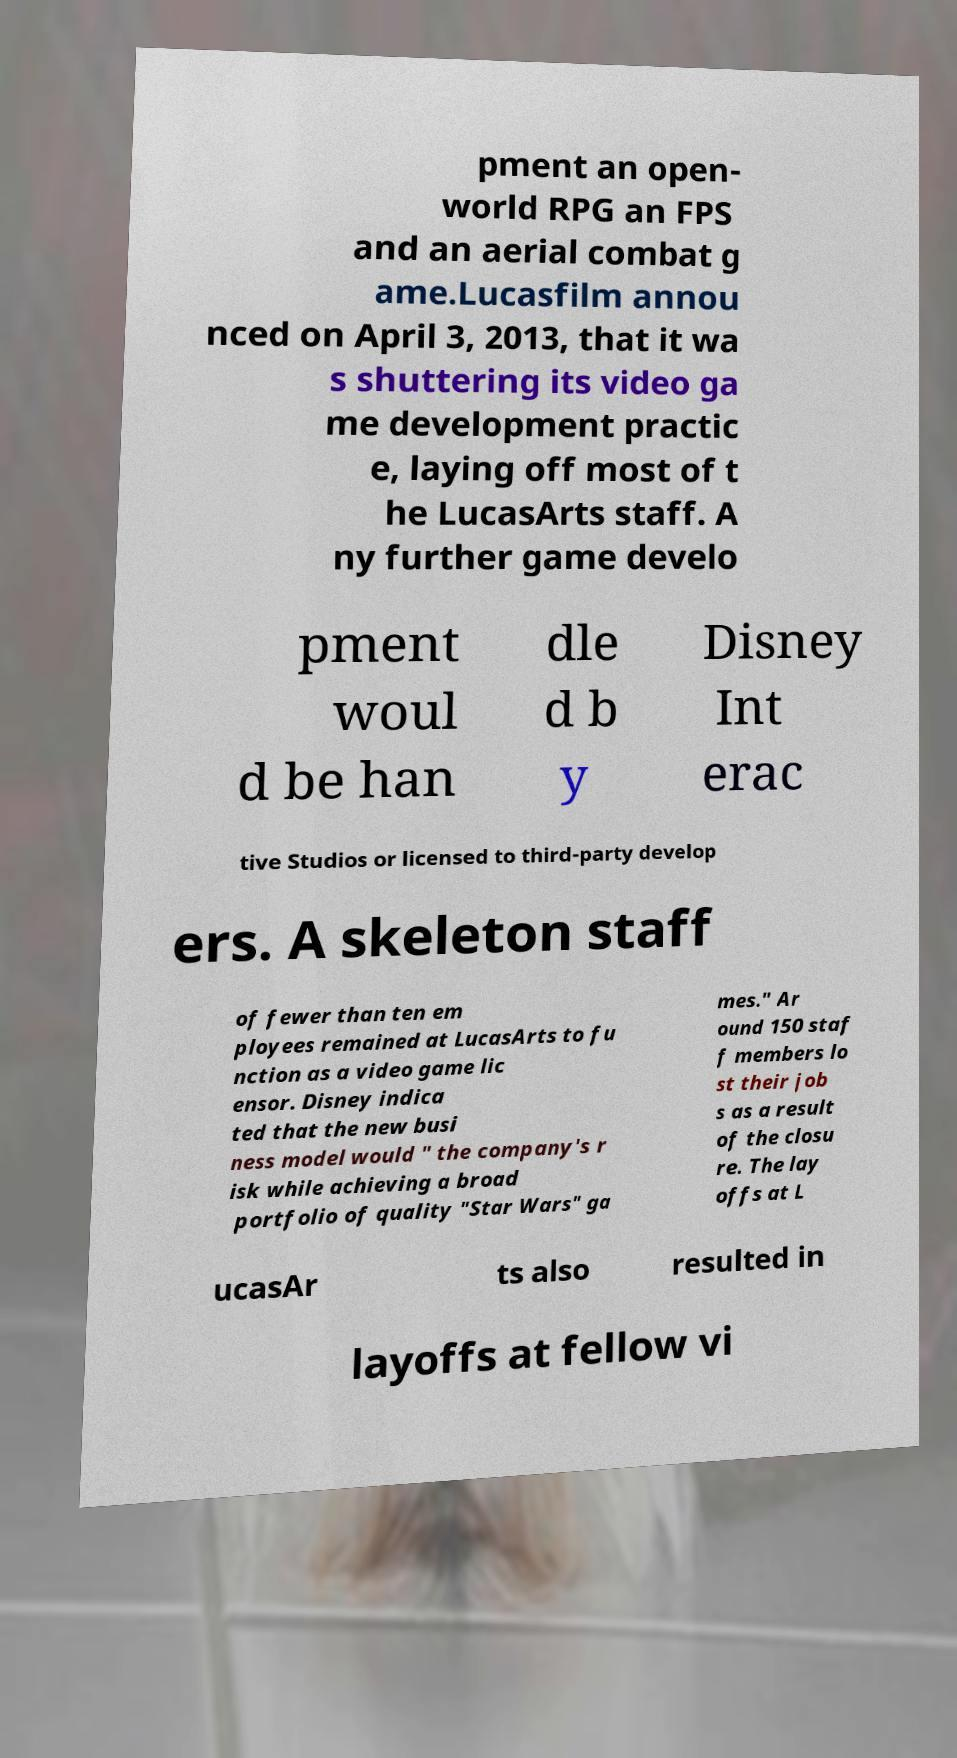Please read and relay the text visible in this image. What does it say? pment an open- world RPG an FPS and an aerial combat g ame.Lucasfilm annou nced on April 3, 2013, that it wa s shuttering its video ga me development practic e, laying off most of t he LucasArts staff. A ny further game develo pment woul d be han dle d b y Disney Int erac tive Studios or licensed to third-party develop ers. A skeleton staff of fewer than ten em ployees remained at LucasArts to fu nction as a video game lic ensor. Disney indica ted that the new busi ness model would " the company's r isk while achieving a broad portfolio of quality "Star Wars" ga mes." Ar ound 150 staf f members lo st their job s as a result of the closu re. The lay offs at L ucasAr ts also resulted in layoffs at fellow vi 